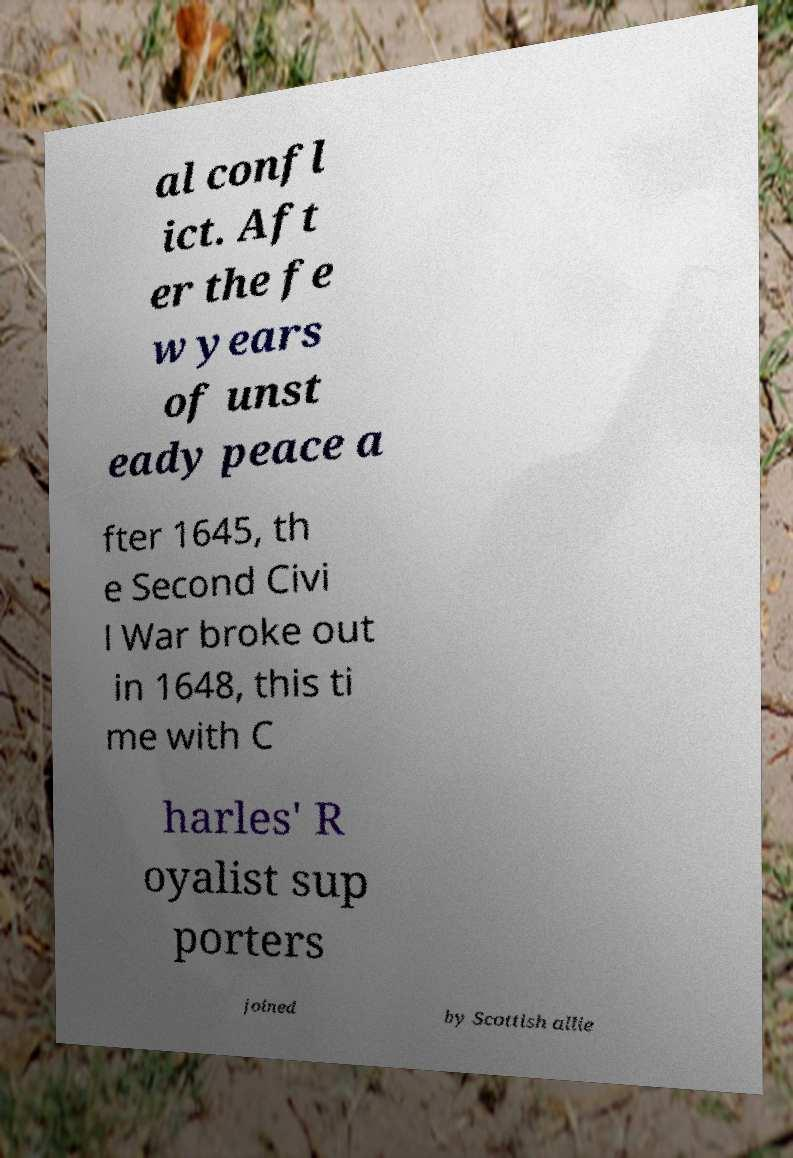There's text embedded in this image that I need extracted. Can you transcribe it verbatim? al confl ict. Aft er the fe w years of unst eady peace a fter 1645, th e Second Civi l War broke out in 1648, this ti me with C harles' R oyalist sup porters joined by Scottish allie 